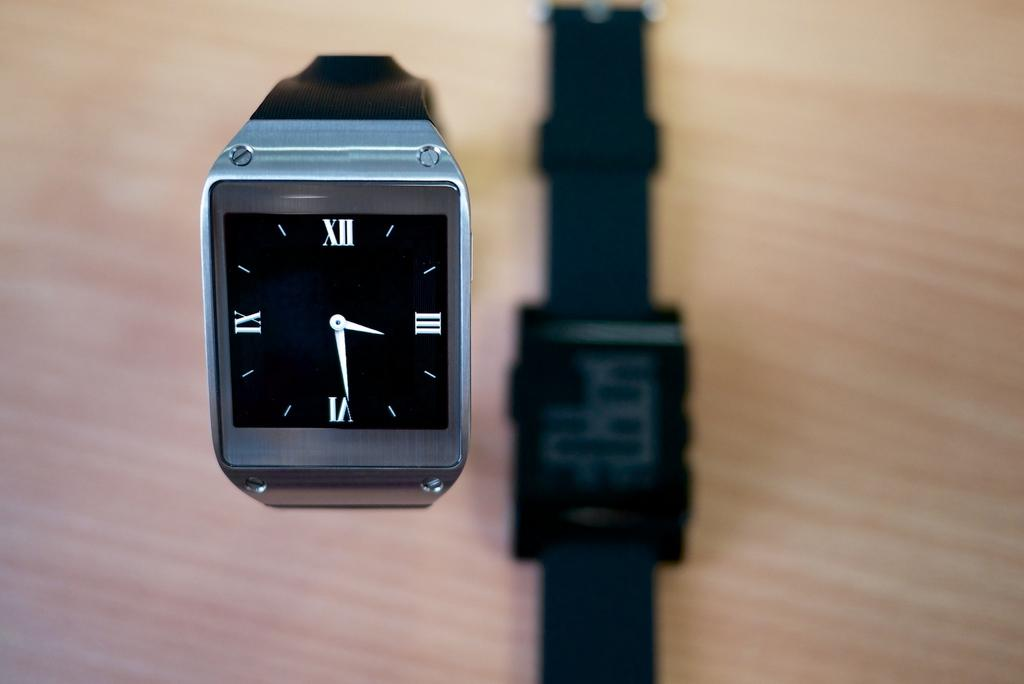<image>
Describe the image concisely. The watch laying on the table has the number 15 on display. 